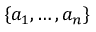<formula> <loc_0><loc_0><loc_500><loc_500>\{ a _ { 1 } , \dots , a _ { n } \}</formula> 